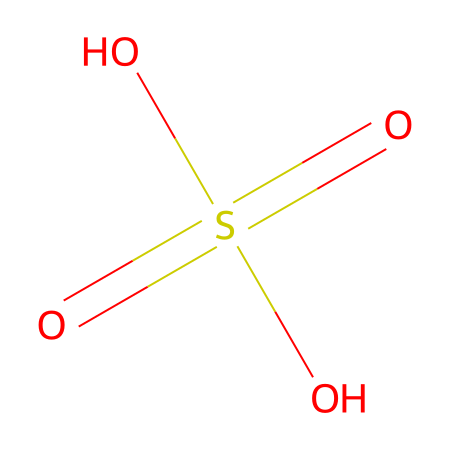What is the name of this chemical? The SMILES representation describes the structure of sulfuric acid, which is a well-known chemical. The specific arrangement of atoms indicates it is indeed sulfuric acid.
Answer: sulfuric acid How many oxygen atoms are present in the structure? By analyzing the structure from the SMILES notation O=S(=O)(O)O, we can count four oxygen atoms that are part of the sulfuric acid molecule.
Answer: four What type of chemical compound is sulfuric acid? Sulfuric acid is classified as an acid due to the presence of hydrogen ions that it can release in solution. This characteristic defines it as a strong acid.
Answer: acid How many sulfur and hydrogen atoms are in sulfuric acid? The structure contains one sulfur atom (from S) and two hydrogen atoms (from the two O-connected H) in the molecular formula of sulfuric acid.
Answer: one sulfur, two hydrogen What is the oxidation state of sulfur in this compound? In sulfuric acid, sulfur is bonded to four oxygen atoms, where two of them are double bonded and two are single bonded (with hydroxyl groups), leading to an oxidation state of +6 for the sulfur atom.
Answer: +6 What potential hazards are associated with sulfuric acid? Sulfuric acid is highly corrosive and can cause severe burns upon contact with skin or eyes, and it can also react violently with water or organic materials.
Answer: corrosive 